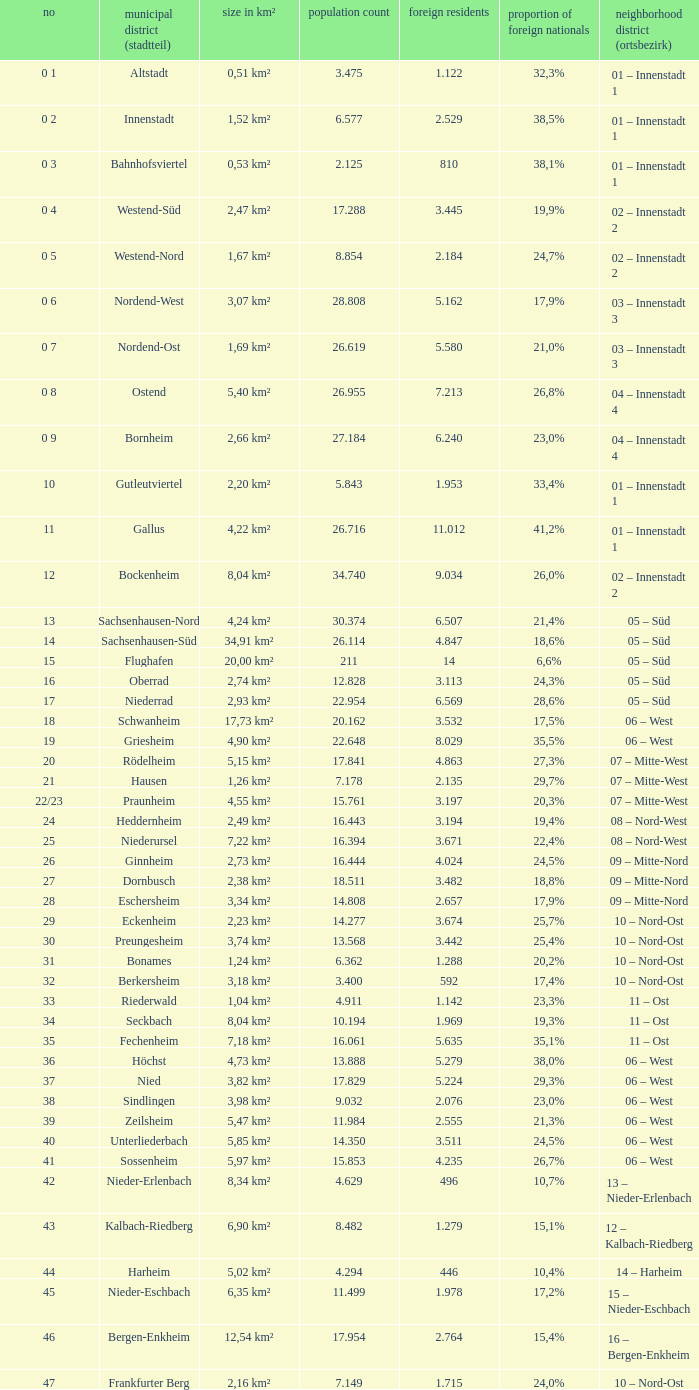How many foreigners in percentage terms had a population of 4.911? 1.0. 